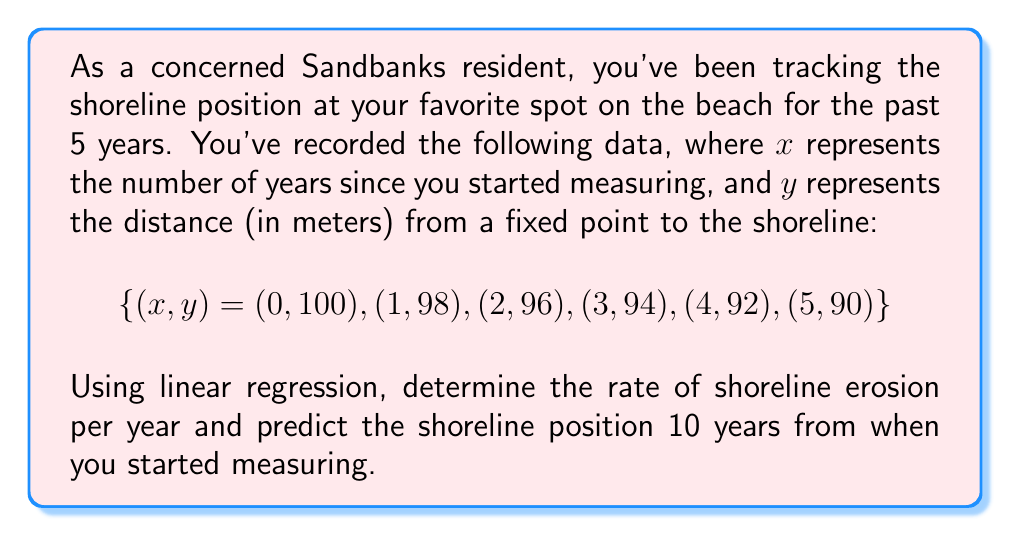Could you help me with this problem? To solve this problem, we'll use linear regression to find the best-fit line for the data and determine the rate of erosion. Then, we'll use the resulting equation to predict the future shoreline position.

Step 1: Calculate the means of x and y
$$\bar{x} = \frac{0 + 1 + 2 + 3 + 4 + 5}{6} = 2.5$$
$$\bar{y} = \frac{100 + 98 + 96 + 94 + 92 + 90}{6} = 95$$

Step 2: Calculate the slope (m) using the linear regression formula
$$m = \frac{\sum (x_i - \bar{x})(y_i - \bar{y})}{\sum (x_i - \bar{x})^2}$$

$$m = \frac{(-2.5)(5) + (-1.5)(3) + (-0.5)(1) + (0.5)(-1) + (1.5)(-3) + (2.5)(-5)}{(-2.5)^2 + (-1.5)^2 + (-0.5)^2 + (0.5)^2 + (1.5)^2 + (2.5)^2}$$

$$m = \frac{-50}{17.5} = -2$$

The slope represents the rate of shoreline erosion, which is 2 meters per year.

Step 3: Calculate the y-intercept (b) using the point-slope form
$$b = \bar{y} - m\bar{x} = 95 - (-2)(2.5) = 100$$

Step 4: Write the equation of the best-fit line
$$y = mx + b = -2x + 100$$

Step 5: Predict the shoreline position 10 years from the start
$$y = -2(10) + 100 = 80$$

Therefore, the predicted shoreline position after 10 years is 80 meters from the fixed point.
Answer: Erosion rate: 2 m/year; Predicted position after 10 years: 80 m 